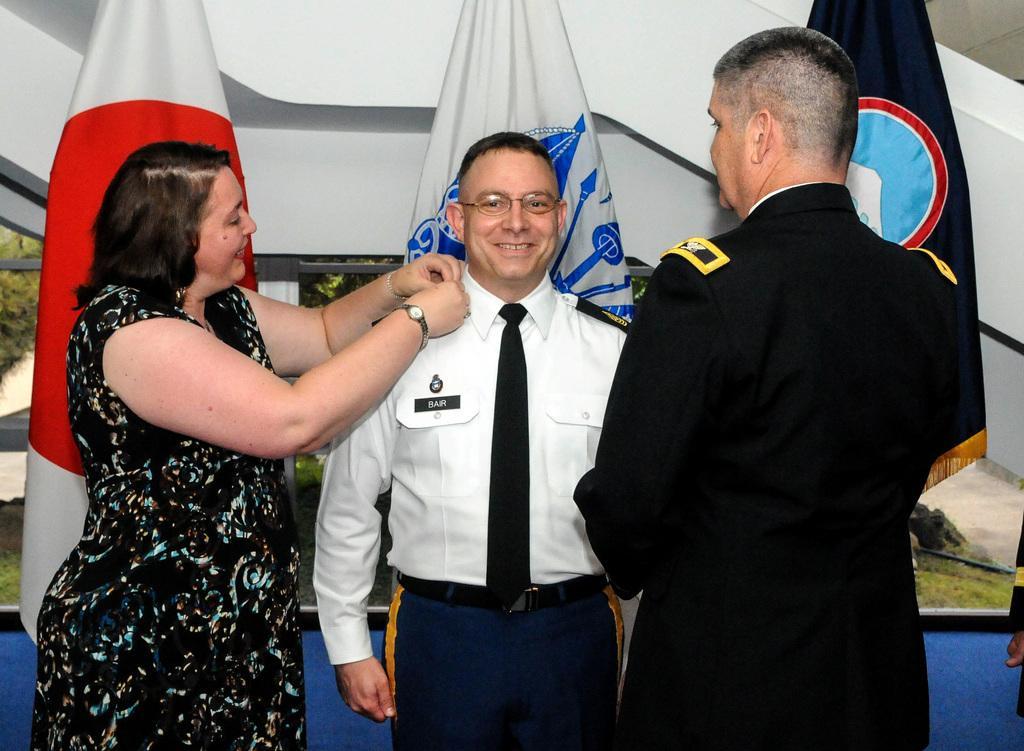Describe this image in one or two sentences. There are two men and a woman standing and smiling. These are the flags hanging to the poles. In the background, that looks like a wall. 